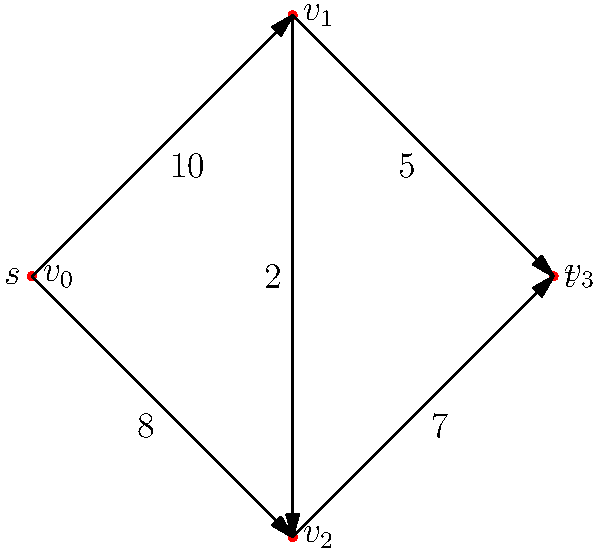In the spirit of Mr. Miyagi's wisdom, "Balance is key, Daniel-san," consider the following network flow problem. Given the directed graph above with vertex $v_0$ as the source $s$ and vertex $v_3$ as the sink $t$, what is the maximum flow from $s$ to $t$? Remember, just as in karate, the flow must be balanced at each intermediate vertex. Let's approach this step-by-step, like Mr. Miyagi would teach a karate move:

1) First, observe the graph. We have 4 vertices, with $v_0$ as the source and $v_3$ as the sink.

2) There are two paths from source to sink:
   Path 1: $v_0 \rightarrow v_1 \rightarrow v_3$
   Path 2: $v_0 \rightarrow v_2 \rightarrow v_3$

3) We also have a cross edge $v_1 \rightarrow v_2$ with capacity 2.

4) Let's start pushing flow through Path 1:
   - We can push 10 units from $v_0$ to $v_1$
   - But we can only push 5 units from $v_1$ to $v_3$
   So, we push 5 units through Path 1.

5) Now, let's look at Path 2:
   - We can push 8 units from $v_0$ to $v_2$
   - We can push 7 units from $v_2$ to $v_3$
   So, we push 7 units through Path 2.

6) At this point, we've pushed 12 units in total (5 + 7).

7) Can we do better? Yes! Remember the cross edge $v_1 \rightarrow v_2$:
   - We still have 5 units of unused capacity from $v_0$ to $v_1$
   - We can push 2 of these units from $v_1$ to $v_2$
   - There's still 1 unit of unused capacity from $v_2$ to $v_3$

8) So, we can push 1 more unit: $v_0 \rightarrow v_1 \rightarrow v_2 \rightarrow v_3$

Therefore, the maximum flow is 12 + 1 = 13 units.
Answer: 13 units 